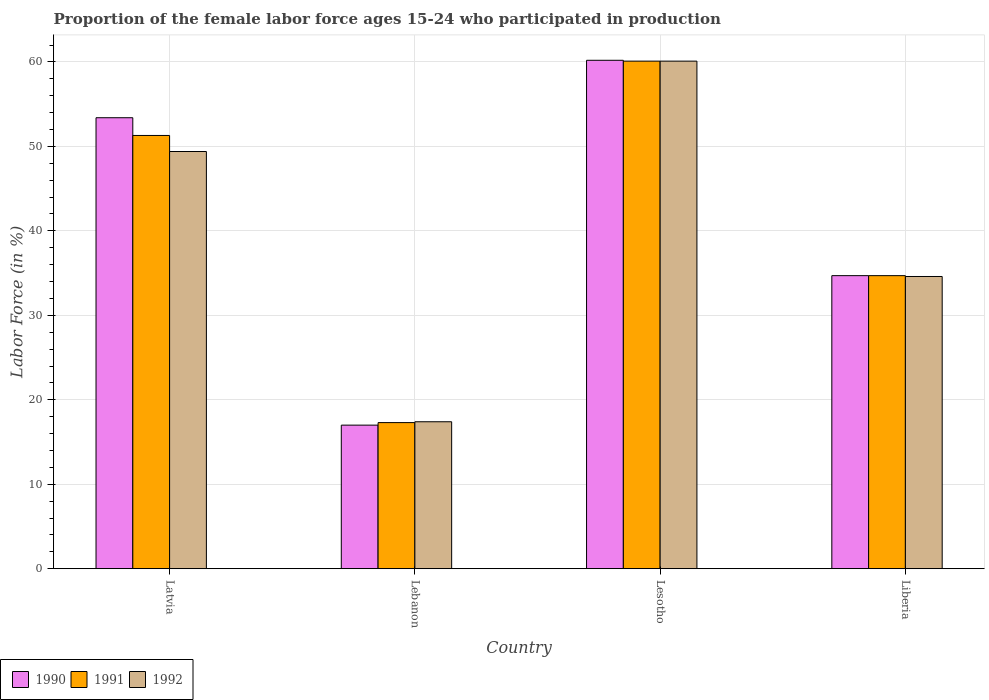How many different coloured bars are there?
Give a very brief answer. 3. How many groups of bars are there?
Your answer should be compact. 4. Are the number of bars per tick equal to the number of legend labels?
Make the answer very short. Yes. How many bars are there on the 2nd tick from the left?
Provide a short and direct response. 3. How many bars are there on the 4th tick from the right?
Provide a succinct answer. 3. What is the label of the 1st group of bars from the left?
Offer a very short reply. Latvia. What is the proportion of the female labor force who participated in production in 1991 in Lesotho?
Ensure brevity in your answer.  60.1. Across all countries, what is the maximum proportion of the female labor force who participated in production in 1990?
Your answer should be very brief. 60.2. Across all countries, what is the minimum proportion of the female labor force who participated in production in 1992?
Offer a very short reply. 17.4. In which country was the proportion of the female labor force who participated in production in 1991 maximum?
Make the answer very short. Lesotho. In which country was the proportion of the female labor force who participated in production in 1991 minimum?
Give a very brief answer. Lebanon. What is the total proportion of the female labor force who participated in production in 1992 in the graph?
Ensure brevity in your answer.  161.5. What is the difference between the proportion of the female labor force who participated in production in 1992 in Latvia and that in Liberia?
Offer a very short reply. 14.8. What is the difference between the proportion of the female labor force who participated in production in 1991 in Lesotho and the proportion of the female labor force who participated in production in 1990 in Latvia?
Your response must be concise. 6.7. What is the average proportion of the female labor force who participated in production in 1990 per country?
Give a very brief answer. 41.33. What is the difference between the proportion of the female labor force who participated in production of/in 1991 and proportion of the female labor force who participated in production of/in 1990 in Lesotho?
Provide a short and direct response. -0.1. What is the ratio of the proportion of the female labor force who participated in production in 1990 in Latvia to that in Lesotho?
Offer a very short reply. 0.89. Is the difference between the proportion of the female labor force who participated in production in 1991 in Lesotho and Liberia greater than the difference between the proportion of the female labor force who participated in production in 1990 in Lesotho and Liberia?
Your response must be concise. No. What is the difference between the highest and the second highest proportion of the female labor force who participated in production in 1991?
Make the answer very short. -16.6. What is the difference between the highest and the lowest proportion of the female labor force who participated in production in 1991?
Provide a succinct answer. 42.8. In how many countries, is the proportion of the female labor force who participated in production in 1991 greater than the average proportion of the female labor force who participated in production in 1991 taken over all countries?
Offer a very short reply. 2. What does the 2nd bar from the right in Liberia represents?
Your answer should be very brief. 1991. Is it the case that in every country, the sum of the proportion of the female labor force who participated in production in 1992 and proportion of the female labor force who participated in production in 1990 is greater than the proportion of the female labor force who participated in production in 1991?
Ensure brevity in your answer.  Yes. How many bars are there?
Your answer should be compact. 12. Are all the bars in the graph horizontal?
Offer a terse response. No. What is the difference between two consecutive major ticks on the Y-axis?
Ensure brevity in your answer.  10. Are the values on the major ticks of Y-axis written in scientific E-notation?
Make the answer very short. No. Does the graph contain grids?
Keep it short and to the point. Yes. What is the title of the graph?
Ensure brevity in your answer.  Proportion of the female labor force ages 15-24 who participated in production. Does "2011" appear as one of the legend labels in the graph?
Offer a very short reply. No. What is the Labor Force (in %) of 1990 in Latvia?
Provide a succinct answer. 53.4. What is the Labor Force (in %) in 1991 in Latvia?
Keep it short and to the point. 51.3. What is the Labor Force (in %) in 1992 in Latvia?
Provide a succinct answer. 49.4. What is the Labor Force (in %) of 1990 in Lebanon?
Offer a very short reply. 17. What is the Labor Force (in %) of 1991 in Lebanon?
Your answer should be compact. 17.3. What is the Labor Force (in %) of 1992 in Lebanon?
Your answer should be very brief. 17.4. What is the Labor Force (in %) of 1990 in Lesotho?
Provide a short and direct response. 60.2. What is the Labor Force (in %) of 1991 in Lesotho?
Ensure brevity in your answer.  60.1. What is the Labor Force (in %) in 1992 in Lesotho?
Provide a succinct answer. 60.1. What is the Labor Force (in %) in 1990 in Liberia?
Make the answer very short. 34.7. What is the Labor Force (in %) of 1991 in Liberia?
Your response must be concise. 34.7. What is the Labor Force (in %) of 1992 in Liberia?
Provide a succinct answer. 34.6. Across all countries, what is the maximum Labor Force (in %) of 1990?
Offer a terse response. 60.2. Across all countries, what is the maximum Labor Force (in %) of 1991?
Your answer should be compact. 60.1. Across all countries, what is the maximum Labor Force (in %) in 1992?
Ensure brevity in your answer.  60.1. Across all countries, what is the minimum Labor Force (in %) of 1991?
Your answer should be compact. 17.3. Across all countries, what is the minimum Labor Force (in %) of 1992?
Ensure brevity in your answer.  17.4. What is the total Labor Force (in %) of 1990 in the graph?
Offer a terse response. 165.3. What is the total Labor Force (in %) of 1991 in the graph?
Keep it short and to the point. 163.4. What is the total Labor Force (in %) of 1992 in the graph?
Ensure brevity in your answer.  161.5. What is the difference between the Labor Force (in %) of 1990 in Latvia and that in Lebanon?
Offer a very short reply. 36.4. What is the difference between the Labor Force (in %) of 1992 in Latvia and that in Lebanon?
Offer a very short reply. 32. What is the difference between the Labor Force (in %) in 1992 in Latvia and that in Lesotho?
Provide a succinct answer. -10.7. What is the difference between the Labor Force (in %) in 1990 in Latvia and that in Liberia?
Offer a very short reply. 18.7. What is the difference between the Labor Force (in %) in 1992 in Latvia and that in Liberia?
Ensure brevity in your answer.  14.8. What is the difference between the Labor Force (in %) in 1990 in Lebanon and that in Lesotho?
Ensure brevity in your answer.  -43.2. What is the difference between the Labor Force (in %) of 1991 in Lebanon and that in Lesotho?
Ensure brevity in your answer.  -42.8. What is the difference between the Labor Force (in %) of 1992 in Lebanon and that in Lesotho?
Provide a succinct answer. -42.7. What is the difference between the Labor Force (in %) in 1990 in Lebanon and that in Liberia?
Your response must be concise. -17.7. What is the difference between the Labor Force (in %) in 1991 in Lebanon and that in Liberia?
Your answer should be compact. -17.4. What is the difference between the Labor Force (in %) in 1992 in Lebanon and that in Liberia?
Ensure brevity in your answer.  -17.2. What is the difference between the Labor Force (in %) of 1991 in Lesotho and that in Liberia?
Your response must be concise. 25.4. What is the difference between the Labor Force (in %) of 1992 in Lesotho and that in Liberia?
Offer a terse response. 25.5. What is the difference between the Labor Force (in %) of 1990 in Latvia and the Labor Force (in %) of 1991 in Lebanon?
Keep it short and to the point. 36.1. What is the difference between the Labor Force (in %) in 1990 in Latvia and the Labor Force (in %) in 1992 in Lebanon?
Ensure brevity in your answer.  36. What is the difference between the Labor Force (in %) in 1991 in Latvia and the Labor Force (in %) in 1992 in Lebanon?
Give a very brief answer. 33.9. What is the difference between the Labor Force (in %) in 1990 in Latvia and the Labor Force (in %) in 1991 in Lesotho?
Your response must be concise. -6.7. What is the difference between the Labor Force (in %) of 1990 in Latvia and the Labor Force (in %) of 1992 in Lesotho?
Keep it short and to the point. -6.7. What is the difference between the Labor Force (in %) of 1990 in Lebanon and the Labor Force (in %) of 1991 in Lesotho?
Give a very brief answer. -43.1. What is the difference between the Labor Force (in %) in 1990 in Lebanon and the Labor Force (in %) in 1992 in Lesotho?
Your answer should be compact. -43.1. What is the difference between the Labor Force (in %) in 1991 in Lebanon and the Labor Force (in %) in 1992 in Lesotho?
Ensure brevity in your answer.  -42.8. What is the difference between the Labor Force (in %) in 1990 in Lebanon and the Labor Force (in %) in 1991 in Liberia?
Offer a very short reply. -17.7. What is the difference between the Labor Force (in %) of 1990 in Lebanon and the Labor Force (in %) of 1992 in Liberia?
Provide a succinct answer. -17.6. What is the difference between the Labor Force (in %) of 1991 in Lebanon and the Labor Force (in %) of 1992 in Liberia?
Provide a short and direct response. -17.3. What is the difference between the Labor Force (in %) in 1990 in Lesotho and the Labor Force (in %) in 1992 in Liberia?
Your answer should be very brief. 25.6. What is the average Labor Force (in %) of 1990 per country?
Make the answer very short. 41.33. What is the average Labor Force (in %) in 1991 per country?
Offer a very short reply. 40.85. What is the average Labor Force (in %) of 1992 per country?
Ensure brevity in your answer.  40.38. What is the difference between the Labor Force (in %) of 1990 and Labor Force (in %) of 1991 in Latvia?
Your answer should be very brief. 2.1. What is the difference between the Labor Force (in %) of 1990 and Labor Force (in %) of 1992 in Latvia?
Make the answer very short. 4. What is the difference between the Labor Force (in %) in 1991 and Labor Force (in %) in 1992 in Latvia?
Keep it short and to the point. 1.9. What is the difference between the Labor Force (in %) in 1990 and Labor Force (in %) in 1991 in Lebanon?
Your response must be concise. -0.3. What is the difference between the Labor Force (in %) of 1991 and Labor Force (in %) of 1992 in Lebanon?
Offer a terse response. -0.1. What is the difference between the Labor Force (in %) in 1990 and Labor Force (in %) in 1991 in Lesotho?
Your answer should be compact. 0.1. What is the difference between the Labor Force (in %) of 1991 and Labor Force (in %) of 1992 in Lesotho?
Keep it short and to the point. 0. What is the difference between the Labor Force (in %) in 1990 and Labor Force (in %) in 1991 in Liberia?
Your answer should be compact. 0. What is the difference between the Labor Force (in %) in 1990 and Labor Force (in %) in 1992 in Liberia?
Keep it short and to the point. 0.1. What is the ratio of the Labor Force (in %) of 1990 in Latvia to that in Lebanon?
Ensure brevity in your answer.  3.14. What is the ratio of the Labor Force (in %) of 1991 in Latvia to that in Lebanon?
Keep it short and to the point. 2.97. What is the ratio of the Labor Force (in %) of 1992 in Latvia to that in Lebanon?
Give a very brief answer. 2.84. What is the ratio of the Labor Force (in %) of 1990 in Latvia to that in Lesotho?
Give a very brief answer. 0.89. What is the ratio of the Labor Force (in %) in 1991 in Latvia to that in Lesotho?
Your answer should be compact. 0.85. What is the ratio of the Labor Force (in %) of 1992 in Latvia to that in Lesotho?
Your answer should be compact. 0.82. What is the ratio of the Labor Force (in %) of 1990 in Latvia to that in Liberia?
Make the answer very short. 1.54. What is the ratio of the Labor Force (in %) in 1991 in Latvia to that in Liberia?
Make the answer very short. 1.48. What is the ratio of the Labor Force (in %) of 1992 in Latvia to that in Liberia?
Keep it short and to the point. 1.43. What is the ratio of the Labor Force (in %) in 1990 in Lebanon to that in Lesotho?
Your response must be concise. 0.28. What is the ratio of the Labor Force (in %) of 1991 in Lebanon to that in Lesotho?
Offer a terse response. 0.29. What is the ratio of the Labor Force (in %) in 1992 in Lebanon to that in Lesotho?
Provide a succinct answer. 0.29. What is the ratio of the Labor Force (in %) in 1990 in Lebanon to that in Liberia?
Give a very brief answer. 0.49. What is the ratio of the Labor Force (in %) in 1991 in Lebanon to that in Liberia?
Make the answer very short. 0.5. What is the ratio of the Labor Force (in %) in 1992 in Lebanon to that in Liberia?
Make the answer very short. 0.5. What is the ratio of the Labor Force (in %) in 1990 in Lesotho to that in Liberia?
Your answer should be very brief. 1.73. What is the ratio of the Labor Force (in %) in 1991 in Lesotho to that in Liberia?
Offer a terse response. 1.73. What is the ratio of the Labor Force (in %) in 1992 in Lesotho to that in Liberia?
Give a very brief answer. 1.74. What is the difference between the highest and the lowest Labor Force (in %) of 1990?
Offer a very short reply. 43.2. What is the difference between the highest and the lowest Labor Force (in %) of 1991?
Provide a short and direct response. 42.8. What is the difference between the highest and the lowest Labor Force (in %) of 1992?
Make the answer very short. 42.7. 